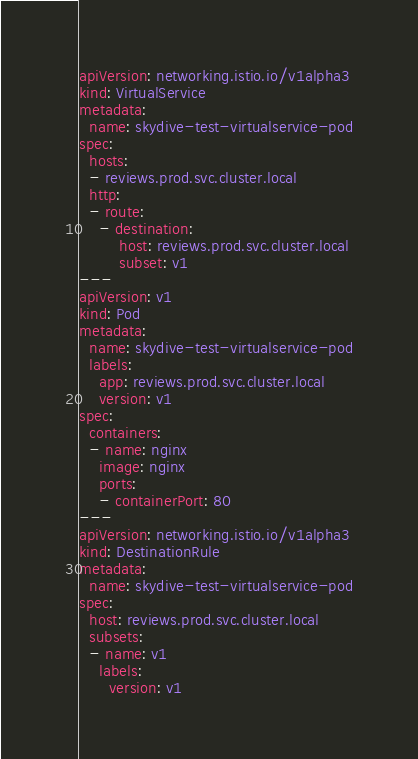<code> <loc_0><loc_0><loc_500><loc_500><_YAML_>apiVersion: networking.istio.io/v1alpha3
kind: VirtualService
metadata:
  name: skydive-test-virtualservice-pod
spec:
  hosts:
  - reviews.prod.svc.cluster.local
  http:
  - route:
    - destination:
        host: reviews.prod.svc.cluster.local
        subset: v1
---
apiVersion: v1
kind: Pod
metadata:
  name: skydive-test-virtualservice-pod
  labels:
    app: reviews.prod.svc.cluster.local
    version: v1
spec:
  containers:
  - name: nginx
    image: nginx
    ports:
    - containerPort: 80
---
apiVersion: networking.istio.io/v1alpha3
kind: DestinationRule
metadata:
  name: skydive-test-virtualservice-pod
spec:
  host: reviews.prod.svc.cluster.local
  subsets:
  - name: v1
    labels:
      version: v1
</code> 